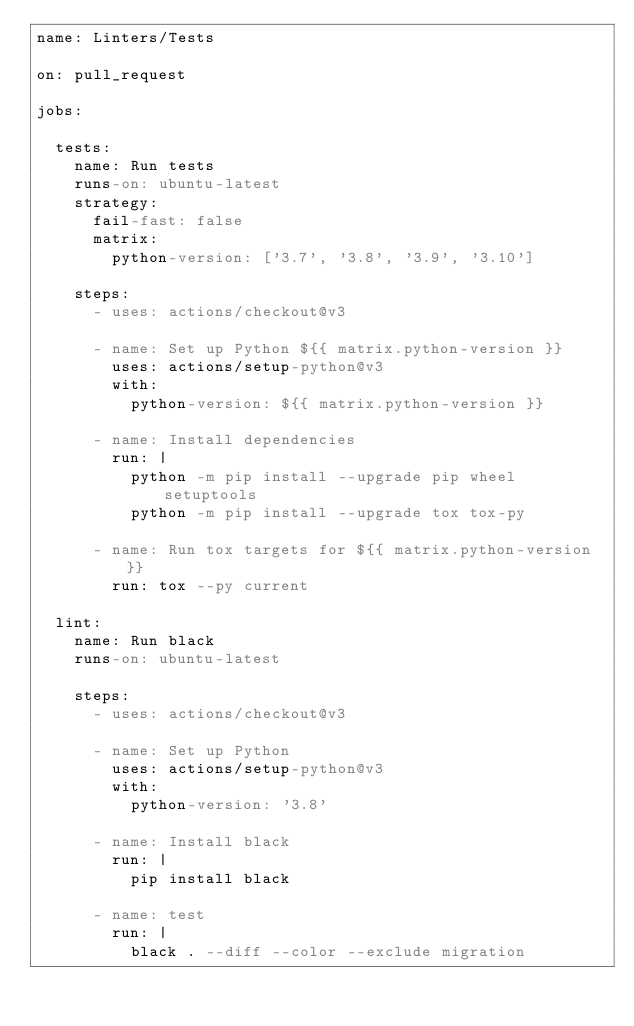Convert code to text. <code><loc_0><loc_0><loc_500><loc_500><_YAML_>name: Linters/Tests

on: pull_request

jobs:

  tests:
    name: Run tests
    runs-on: ubuntu-latest
    strategy:
      fail-fast: false
      matrix:
        python-version: ['3.7', '3.8', '3.9', '3.10']

    steps:
      - uses: actions/checkout@v3

      - name: Set up Python ${{ matrix.python-version }}
        uses: actions/setup-python@v3
        with:
          python-version: ${{ matrix.python-version }}

      - name: Install dependencies
        run: |
          python -m pip install --upgrade pip wheel setuptools
          python -m pip install --upgrade tox tox-py

      - name: Run tox targets for ${{ matrix.python-version }}
        run: tox --py current

  lint:
    name: Run black
    runs-on: ubuntu-latest

    steps:
      - uses: actions/checkout@v3

      - name: Set up Python
        uses: actions/setup-python@v3
        with:
          python-version: '3.8'

      - name: Install black
        run: |
          pip install black

      - name: test
        run: |
          black . --diff --color --exclude migration

</code> 